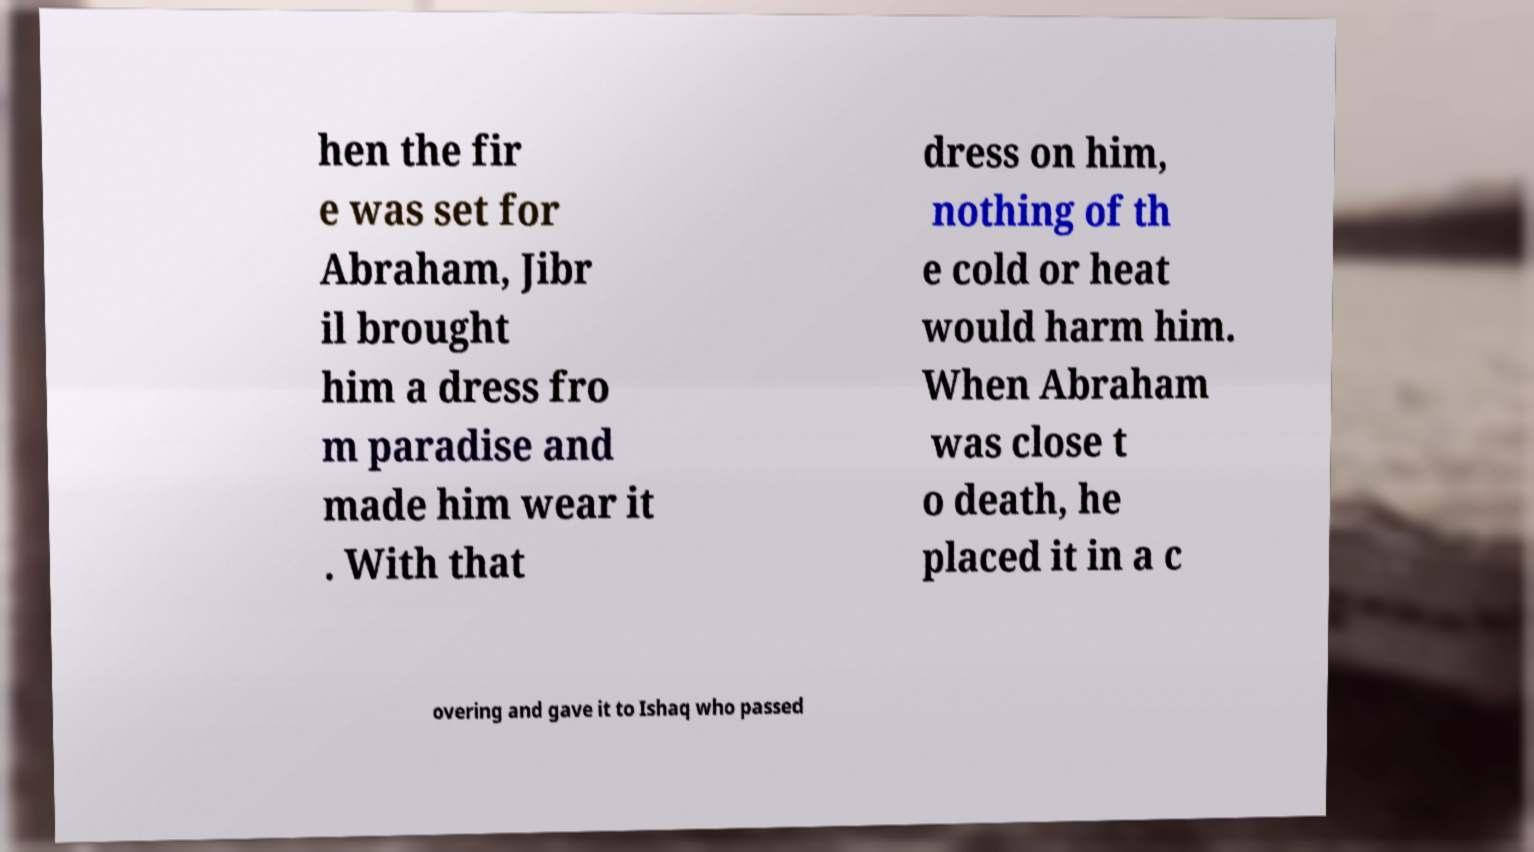Could you assist in decoding the text presented in this image and type it out clearly? hen the fir e was set for Abraham, Jibr il brought him a dress fro m paradise and made him wear it . With that dress on him, nothing of th e cold or heat would harm him. When Abraham was close t o death, he placed it in a c overing and gave it to Ishaq who passed 